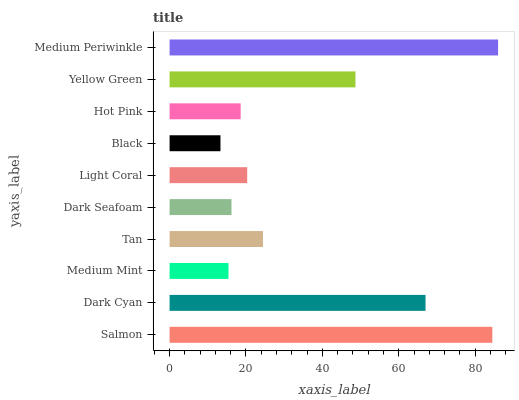Is Black the minimum?
Answer yes or no. Yes. Is Medium Periwinkle the maximum?
Answer yes or no. Yes. Is Dark Cyan the minimum?
Answer yes or no. No. Is Dark Cyan the maximum?
Answer yes or no. No. Is Salmon greater than Dark Cyan?
Answer yes or no. Yes. Is Dark Cyan less than Salmon?
Answer yes or no. Yes. Is Dark Cyan greater than Salmon?
Answer yes or no. No. Is Salmon less than Dark Cyan?
Answer yes or no. No. Is Tan the high median?
Answer yes or no. Yes. Is Light Coral the low median?
Answer yes or no. Yes. Is Hot Pink the high median?
Answer yes or no. No. Is Tan the low median?
Answer yes or no. No. 